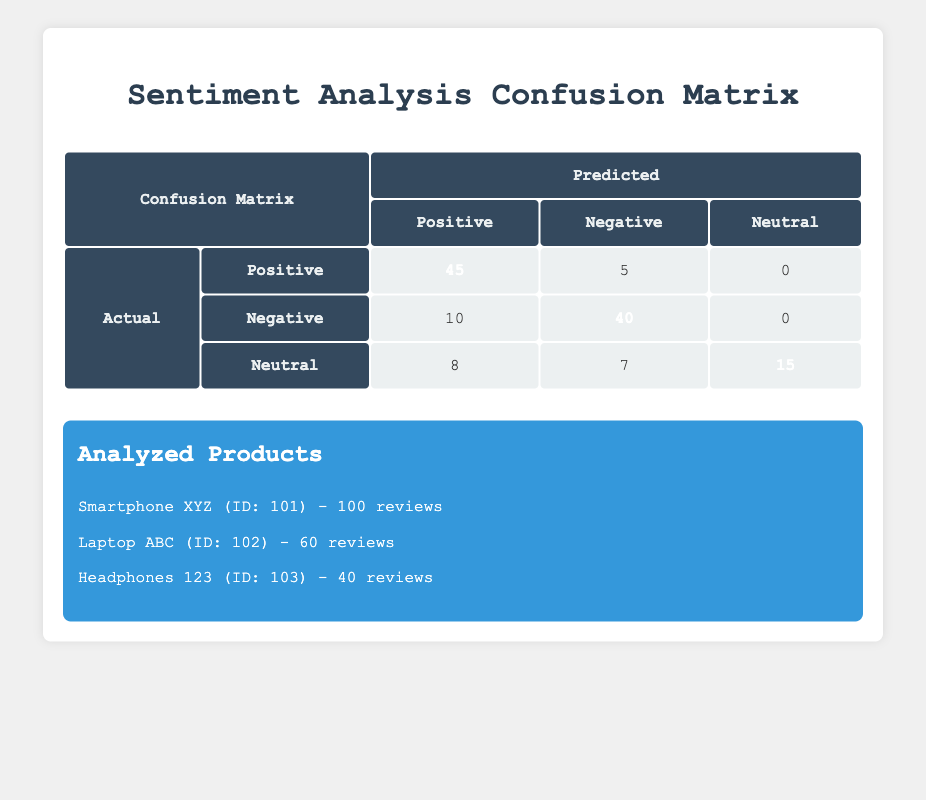What is the count of positive reviews that were correctly predicted? From the 'Confusion Matrix' in the table, under 'Actual Positive', the count of 'Predicted Positive' is 45. This indicates the number of positive reviews that were correctly identified.
Answer: 45 What is the total number of actual negative reviews predicted as positive? The table shows that under 'Actual Negative', the count of 'Predicted Positive' is 10. So, there were 10 actual negative reviews that were incorrectly predicted as positive.
Answer: 10 What is the count of reviews that were predicted as neutral? In the 'Confusion Matrix', looking at the 'Predicted' column, we see that the total for 'Neutral' includes positive and negative actual classes. Adding the 'Actual Neutral' row, the predicted neutrals are 15 (neutral correct prediction) + 8 (incorrectly positive) + 7 (incorrectly negative) = 30.
Answer: 30 Is the number of actual positive reviews greater than the number of actual negative reviews? The sum of actual Positive reviews is 50 (45 correct + 5 incorrect), and actual Negative reviews is 50 (10 incorrect + 40 correct). Hence, they are equal.
Answer: No How many reviews were predicted as negative across all actual categories? In the 'Confusion Matrix', the 'Predicted Negative' column shows values of 5 (from Actual Positive), 40 (from Actual Negative) and 7 (from Actual Neutral). Adding these gives us a total of 5 + 40 + 7 = 52 reviews predicted as negative.
Answer: 52 What percentage of neutral reviews were correctly predicted? The count of actual neutral reviews is 15, and the count correctly predicted as neutral is also 15. Hence, the percentage is (15/15) * 100 = 100%.
Answer: 100% Which product has the highest review count? Looking at the products listed, the review counts are: Smartphone XYZ (100), Laptop ABC (60), and Headphones 123 (40). Smartphone XYZ has the highest count of 100.
Answer: Smartphone XYZ What is the total count of positive predictions made? By adding all values under the 'Predicted Positive' column, we get 45 (Actual Positive) + 10 (Actual Negative) + 8 (Actual Neutral) = 63.
Answer: 63 What is the difference between the correctly predicted positive and negative reviews? Correctly predicted positive reviews are 45 and correctly predicted negative reviews are 40. The difference is 45 - 40 = 5.
Answer: 5 